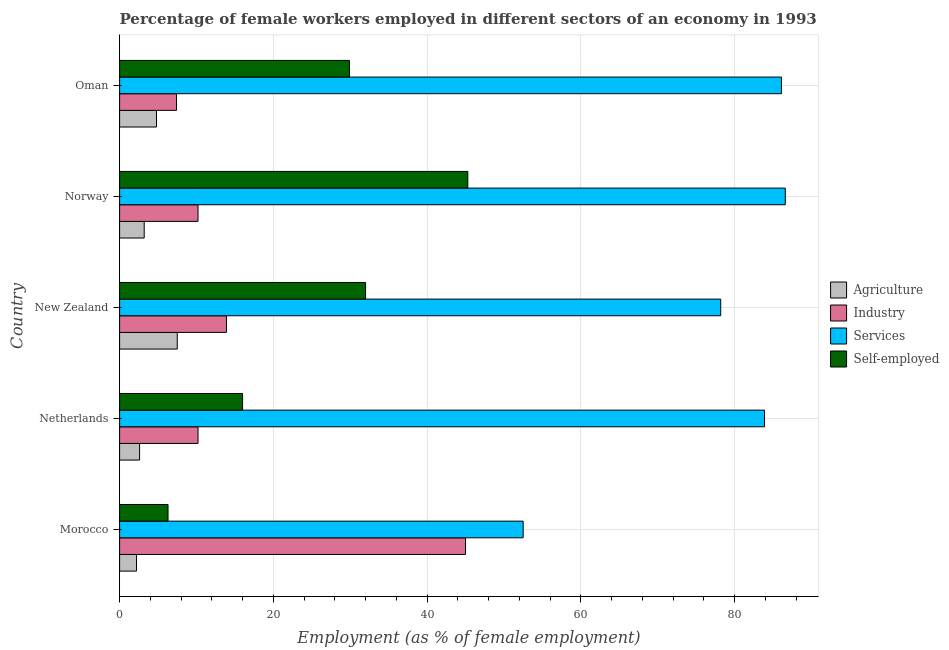Are the number of bars on each tick of the Y-axis equal?
Your answer should be very brief. Yes. What is the label of the 1st group of bars from the top?
Keep it short and to the point. Oman. What is the percentage of female workers in industry in New Zealand?
Keep it short and to the point. 13.9. Across all countries, what is the maximum percentage of self employed female workers?
Keep it short and to the point. 45.3. Across all countries, what is the minimum percentage of self employed female workers?
Provide a short and direct response. 6.3. In which country was the percentage of female workers in agriculture maximum?
Your response must be concise. New Zealand. In which country was the percentage of female workers in agriculture minimum?
Your answer should be compact. Morocco. What is the total percentage of female workers in agriculture in the graph?
Keep it short and to the point. 20.3. What is the difference between the percentage of female workers in agriculture in Norway and the percentage of female workers in industry in Morocco?
Offer a terse response. -41.8. What is the average percentage of female workers in agriculture per country?
Provide a succinct answer. 4.06. What is the difference between the percentage of female workers in agriculture and percentage of female workers in industry in Morocco?
Your response must be concise. -42.8. In how many countries, is the percentage of self employed female workers greater than 32 %?
Your answer should be very brief. 1. What is the ratio of the percentage of self employed female workers in Morocco to that in Norway?
Ensure brevity in your answer.  0.14. Is the difference between the percentage of self employed female workers in Morocco and New Zealand greater than the difference between the percentage of female workers in services in Morocco and New Zealand?
Offer a terse response. No. What is the difference between the highest and the second highest percentage of self employed female workers?
Your answer should be compact. 13.3. What is the difference between the highest and the lowest percentage of female workers in industry?
Give a very brief answer. 37.6. In how many countries, is the percentage of female workers in industry greater than the average percentage of female workers in industry taken over all countries?
Keep it short and to the point. 1. What does the 2nd bar from the top in Morocco represents?
Provide a short and direct response. Services. What does the 4th bar from the bottom in Oman represents?
Give a very brief answer. Self-employed. Is it the case that in every country, the sum of the percentage of female workers in agriculture and percentage of female workers in industry is greater than the percentage of female workers in services?
Provide a succinct answer. No. How many bars are there?
Make the answer very short. 20. How many countries are there in the graph?
Your response must be concise. 5. Does the graph contain any zero values?
Ensure brevity in your answer.  No. Where does the legend appear in the graph?
Your answer should be very brief. Center right. How many legend labels are there?
Your answer should be compact. 4. What is the title of the graph?
Your answer should be very brief. Percentage of female workers employed in different sectors of an economy in 1993. What is the label or title of the X-axis?
Make the answer very short. Employment (as % of female employment). What is the Employment (as % of female employment) of Agriculture in Morocco?
Provide a short and direct response. 2.2. What is the Employment (as % of female employment) of Services in Morocco?
Keep it short and to the point. 52.5. What is the Employment (as % of female employment) of Self-employed in Morocco?
Your answer should be very brief. 6.3. What is the Employment (as % of female employment) in Agriculture in Netherlands?
Your answer should be compact. 2.6. What is the Employment (as % of female employment) in Industry in Netherlands?
Offer a very short reply. 10.2. What is the Employment (as % of female employment) in Services in Netherlands?
Your answer should be compact. 83.9. What is the Employment (as % of female employment) of Self-employed in Netherlands?
Your answer should be very brief. 16. What is the Employment (as % of female employment) in Agriculture in New Zealand?
Give a very brief answer. 7.5. What is the Employment (as % of female employment) in Industry in New Zealand?
Give a very brief answer. 13.9. What is the Employment (as % of female employment) in Services in New Zealand?
Offer a very short reply. 78.2. What is the Employment (as % of female employment) in Self-employed in New Zealand?
Provide a succinct answer. 32. What is the Employment (as % of female employment) in Agriculture in Norway?
Your answer should be very brief. 3.2. What is the Employment (as % of female employment) of Industry in Norway?
Ensure brevity in your answer.  10.2. What is the Employment (as % of female employment) of Services in Norway?
Give a very brief answer. 86.6. What is the Employment (as % of female employment) of Self-employed in Norway?
Offer a terse response. 45.3. What is the Employment (as % of female employment) in Agriculture in Oman?
Offer a terse response. 4.8. What is the Employment (as % of female employment) of Industry in Oman?
Provide a short and direct response. 7.4. What is the Employment (as % of female employment) of Services in Oman?
Provide a short and direct response. 86.1. What is the Employment (as % of female employment) of Self-employed in Oman?
Make the answer very short. 29.9. Across all countries, what is the maximum Employment (as % of female employment) in Services?
Your response must be concise. 86.6. Across all countries, what is the maximum Employment (as % of female employment) in Self-employed?
Give a very brief answer. 45.3. Across all countries, what is the minimum Employment (as % of female employment) in Agriculture?
Give a very brief answer. 2.2. Across all countries, what is the minimum Employment (as % of female employment) of Industry?
Make the answer very short. 7.4. Across all countries, what is the minimum Employment (as % of female employment) of Services?
Keep it short and to the point. 52.5. Across all countries, what is the minimum Employment (as % of female employment) of Self-employed?
Give a very brief answer. 6.3. What is the total Employment (as % of female employment) of Agriculture in the graph?
Your response must be concise. 20.3. What is the total Employment (as % of female employment) in Industry in the graph?
Keep it short and to the point. 86.7. What is the total Employment (as % of female employment) of Services in the graph?
Give a very brief answer. 387.3. What is the total Employment (as % of female employment) of Self-employed in the graph?
Keep it short and to the point. 129.5. What is the difference between the Employment (as % of female employment) of Agriculture in Morocco and that in Netherlands?
Your answer should be very brief. -0.4. What is the difference between the Employment (as % of female employment) of Industry in Morocco and that in Netherlands?
Make the answer very short. 34.8. What is the difference between the Employment (as % of female employment) in Services in Morocco and that in Netherlands?
Make the answer very short. -31.4. What is the difference between the Employment (as % of female employment) in Industry in Morocco and that in New Zealand?
Your answer should be very brief. 31.1. What is the difference between the Employment (as % of female employment) of Services in Morocco and that in New Zealand?
Offer a terse response. -25.7. What is the difference between the Employment (as % of female employment) of Self-employed in Morocco and that in New Zealand?
Offer a very short reply. -25.7. What is the difference between the Employment (as % of female employment) in Industry in Morocco and that in Norway?
Provide a succinct answer. 34.8. What is the difference between the Employment (as % of female employment) in Services in Morocco and that in Norway?
Offer a terse response. -34.1. What is the difference between the Employment (as % of female employment) of Self-employed in Morocco and that in Norway?
Give a very brief answer. -39. What is the difference between the Employment (as % of female employment) of Agriculture in Morocco and that in Oman?
Ensure brevity in your answer.  -2.6. What is the difference between the Employment (as % of female employment) in Industry in Morocco and that in Oman?
Offer a terse response. 37.6. What is the difference between the Employment (as % of female employment) in Services in Morocco and that in Oman?
Offer a terse response. -33.6. What is the difference between the Employment (as % of female employment) of Self-employed in Morocco and that in Oman?
Offer a very short reply. -23.6. What is the difference between the Employment (as % of female employment) in Self-employed in Netherlands and that in New Zealand?
Your response must be concise. -16. What is the difference between the Employment (as % of female employment) of Industry in Netherlands and that in Norway?
Offer a very short reply. 0. What is the difference between the Employment (as % of female employment) in Services in Netherlands and that in Norway?
Make the answer very short. -2.7. What is the difference between the Employment (as % of female employment) in Self-employed in Netherlands and that in Norway?
Keep it short and to the point. -29.3. What is the difference between the Employment (as % of female employment) of Agriculture in Netherlands and that in Oman?
Ensure brevity in your answer.  -2.2. What is the difference between the Employment (as % of female employment) in Services in New Zealand and that in Norway?
Provide a succinct answer. -8.4. What is the difference between the Employment (as % of female employment) in Industry in New Zealand and that in Oman?
Offer a terse response. 6.5. What is the difference between the Employment (as % of female employment) of Agriculture in Morocco and the Employment (as % of female employment) of Services in Netherlands?
Keep it short and to the point. -81.7. What is the difference between the Employment (as % of female employment) of Agriculture in Morocco and the Employment (as % of female employment) of Self-employed in Netherlands?
Offer a very short reply. -13.8. What is the difference between the Employment (as % of female employment) in Industry in Morocco and the Employment (as % of female employment) in Services in Netherlands?
Keep it short and to the point. -38.9. What is the difference between the Employment (as % of female employment) of Industry in Morocco and the Employment (as % of female employment) of Self-employed in Netherlands?
Make the answer very short. 29. What is the difference between the Employment (as % of female employment) in Services in Morocco and the Employment (as % of female employment) in Self-employed in Netherlands?
Provide a succinct answer. 36.5. What is the difference between the Employment (as % of female employment) of Agriculture in Morocco and the Employment (as % of female employment) of Industry in New Zealand?
Your answer should be very brief. -11.7. What is the difference between the Employment (as % of female employment) of Agriculture in Morocco and the Employment (as % of female employment) of Services in New Zealand?
Offer a very short reply. -76. What is the difference between the Employment (as % of female employment) of Agriculture in Morocco and the Employment (as % of female employment) of Self-employed in New Zealand?
Your answer should be very brief. -29.8. What is the difference between the Employment (as % of female employment) in Industry in Morocco and the Employment (as % of female employment) in Services in New Zealand?
Offer a terse response. -33.2. What is the difference between the Employment (as % of female employment) in Services in Morocco and the Employment (as % of female employment) in Self-employed in New Zealand?
Offer a terse response. 20.5. What is the difference between the Employment (as % of female employment) of Agriculture in Morocco and the Employment (as % of female employment) of Services in Norway?
Offer a very short reply. -84.4. What is the difference between the Employment (as % of female employment) in Agriculture in Morocco and the Employment (as % of female employment) in Self-employed in Norway?
Keep it short and to the point. -43.1. What is the difference between the Employment (as % of female employment) in Industry in Morocco and the Employment (as % of female employment) in Services in Norway?
Your answer should be compact. -41.6. What is the difference between the Employment (as % of female employment) of Services in Morocco and the Employment (as % of female employment) of Self-employed in Norway?
Your response must be concise. 7.2. What is the difference between the Employment (as % of female employment) of Agriculture in Morocco and the Employment (as % of female employment) of Industry in Oman?
Provide a succinct answer. -5.2. What is the difference between the Employment (as % of female employment) of Agriculture in Morocco and the Employment (as % of female employment) of Services in Oman?
Offer a very short reply. -83.9. What is the difference between the Employment (as % of female employment) of Agriculture in Morocco and the Employment (as % of female employment) of Self-employed in Oman?
Make the answer very short. -27.7. What is the difference between the Employment (as % of female employment) of Industry in Morocco and the Employment (as % of female employment) of Services in Oman?
Your response must be concise. -41.1. What is the difference between the Employment (as % of female employment) in Industry in Morocco and the Employment (as % of female employment) in Self-employed in Oman?
Your response must be concise. 15.1. What is the difference between the Employment (as % of female employment) of Services in Morocco and the Employment (as % of female employment) of Self-employed in Oman?
Your response must be concise. 22.6. What is the difference between the Employment (as % of female employment) of Agriculture in Netherlands and the Employment (as % of female employment) of Industry in New Zealand?
Give a very brief answer. -11.3. What is the difference between the Employment (as % of female employment) in Agriculture in Netherlands and the Employment (as % of female employment) in Services in New Zealand?
Make the answer very short. -75.6. What is the difference between the Employment (as % of female employment) of Agriculture in Netherlands and the Employment (as % of female employment) of Self-employed in New Zealand?
Your answer should be very brief. -29.4. What is the difference between the Employment (as % of female employment) of Industry in Netherlands and the Employment (as % of female employment) of Services in New Zealand?
Offer a very short reply. -68. What is the difference between the Employment (as % of female employment) in Industry in Netherlands and the Employment (as % of female employment) in Self-employed in New Zealand?
Provide a short and direct response. -21.8. What is the difference between the Employment (as % of female employment) in Services in Netherlands and the Employment (as % of female employment) in Self-employed in New Zealand?
Give a very brief answer. 51.9. What is the difference between the Employment (as % of female employment) of Agriculture in Netherlands and the Employment (as % of female employment) of Industry in Norway?
Offer a very short reply. -7.6. What is the difference between the Employment (as % of female employment) in Agriculture in Netherlands and the Employment (as % of female employment) in Services in Norway?
Offer a very short reply. -84. What is the difference between the Employment (as % of female employment) of Agriculture in Netherlands and the Employment (as % of female employment) of Self-employed in Norway?
Your response must be concise. -42.7. What is the difference between the Employment (as % of female employment) in Industry in Netherlands and the Employment (as % of female employment) in Services in Norway?
Give a very brief answer. -76.4. What is the difference between the Employment (as % of female employment) in Industry in Netherlands and the Employment (as % of female employment) in Self-employed in Norway?
Your answer should be compact. -35.1. What is the difference between the Employment (as % of female employment) of Services in Netherlands and the Employment (as % of female employment) of Self-employed in Norway?
Give a very brief answer. 38.6. What is the difference between the Employment (as % of female employment) in Agriculture in Netherlands and the Employment (as % of female employment) in Services in Oman?
Offer a terse response. -83.5. What is the difference between the Employment (as % of female employment) of Agriculture in Netherlands and the Employment (as % of female employment) of Self-employed in Oman?
Ensure brevity in your answer.  -27.3. What is the difference between the Employment (as % of female employment) in Industry in Netherlands and the Employment (as % of female employment) in Services in Oman?
Make the answer very short. -75.9. What is the difference between the Employment (as % of female employment) of Industry in Netherlands and the Employment (as % of female employment) of Self-employed in Oman?
Ensure brevity in your answer.  -19.7. What is the difference between the Employment (as % of female employment) in Agriculture in New Zealand and the Employment (as % of female employment) in Industry in Norway?
Your answer should be very brief. -2.7. What is the difference between the Employment (as % of female employment) in Agriculture in New Zealand and the Employment (as % of female employment) in Services in Norway?
Your response must be concise. -79.1. What is the difference between the Employment (as % of female employment) in Agriculture in New Zealand and the Employment (as % of female employment) in Self-employed in Norway?
Keep it short and to the point. -37.8. What is the difference between the Employment (as % of female employment) of Industry in New Zealand and the Employment (as % of female employment) of Services in Norway?
Your response must be concise. -72.7. What is the difference between the Employment (as % of female employment) of Industry in New Zealand and the Employment (as % of female employment) of Self-employed in Norway?
Your answer should be compact. -31.4. What is the difference between the Employment (as % of female employment) of Services in New Zealand and the Employment (as % of female employment) of Self-employed in Norway?
Make the answer very short. 32.9. What is the difference between the Employment (as % of female employment) of Agriculture in New Zealand and the Employment (as % of female employment) of Services in Oman?
Offer a very short reply. -78.6. What is the difference between the Employment (as % of female employment) of Agriculture in New Zealand and the Employment (as % of female employment) of Self-employed in Oman?
Offer a very short reply. -22.4. What is the difference between the Employment (as % of female employment) of Industry in New Zealand and the Employment (as % of female employment) of Services in Oman?
Provide a short and direct response. -72.2. What is the difference between the Employment (as % of female employment) in Industry in New Zealand and the Employment (as % of female employment) in Self-employed in Oman?
Keep it short and to the point. -16. What is the difference between the Employment (as % of female employment) of Services in New Zealand and the Employment (as % of female employment) of Self-employed in Oman?
Provide a succinct answer. 48.3. What is the difference between the Employment (as % of female employment) in Agriculture in Norway and the Employment (as % of female employment) in Services in Oman?
Give a very brief answer. -82.9. What is the difference between the Employment (as % of female employment) in Agriculture in Norway and the Employment (as % of female employment) in Self-employed in Oman?
Your response must be concise. -26.7. What is the difference between the Employment (as % of female employment) of Industry in Norway and the Employment (as % of female employment) of Services in Oman?
Your answer should be compact. -75.9. What is the difference between the Employment (as % of female employment) of Industry in Norway and the Employment (as % of female employment) of Self-employed in Oman?
Your answer should be very brief. -19.7. What is the difference between the Employment (as % of female employment) of Services in Norway and the Employment (as % of female employment) of Self-employed in Oman?
Offer a very short reply. 56.7. What is the average Employment (as % of female employment) of Agriculture per country?
Ensure brevity in your answer.  4.06. What is the average Employment (as % of female employment) of Industry per country?
Make the answer very short. 17.34. What is the average Employment (as % of female employment) in Services per country?
Your answer should be compact. 77.46. What is the average Employment (as % of female employment) in Self-employed per country?
Offer a very short reply. 25.9. What is the difference between the Employment (as % of female employment) in Agriculture and Employment (as % of female employment) in Industry in Morocco?
Provide a succinct answer. -42.8. What is the difference between the Employment (as % of female employment) of Agriculture and Employment (as % of female employment) of Services in Morocco?
Keep it short and to the point. -50.3. What is the difference between the Employment (as % of female employment) in Agriculture and Employment (as % of female employment) in Self-employed in Morocco?
Ensure brevity in your answer.  -4.1. What is the difference between the Employment (as % of female employment) of Industry and Employment (as % of female employment) of Services in Morocco?
Ensure brevity in your answer.  -7.5. What is the difference between the Employment (as % of female employment) of Industry and Employment (as % of female employment) of Self-employed in Morocco?
Your answer should be compact. 38.7. What is the difference between the Employment (as % of female employment) of Services and Employment (as % of female employment) of Self-employed in Morocco?
Your response must be concise. 46.2. What is the difference between the Employment (as % of female employment) in Agriculture and Employment (as % of female employment) in Services in Netherlands?
Your answer should be compact. -81.3. What is the difference between the Employment (as % of female employment) of Industry and Employment (as % of female employment) of Services in Netherlands?
Offer a terse response. -73.7. What is the difference between the Employment (as % of female employment) of Industry and Employment (as % of female employment) of Self-employed in Netherlands?
Offer a very short reply. -5.8. What is the difference between the Employment (as % of female employment) of Services and Employment (as % of female employment) of Self-employed in Netherlands?
Offer a terse response. 67.9. What is the difference between the Employment (as % of female employment) in Agriculture and Employment (as % of female employment) in Industry in New Zealand?
Provide a succinct answer. -6.4. What is the difference between the Employment (as % of female employment) in Agriculture and Employment (as % of female employment) in Services in New Zealand?
Ensure brevity in your answer.  -70.7. What is the difference between the Employment (as % of female employment) in Agriculture and Employment (as % of female employment) in Self-employed in New Zealand?
Provide a succinct answer. -24.5. What is the difference between the Employment (as % of female employment) of Industry and Employment (as % of female employment) of Services in New Zealand?
Provide a succinct answer. -64.3. What is the difference between the Employment (as % of female employment) in Industry and Employment (as % of female employment) in Self-employed in New Zealand?
Your response must be concise. -18.1. What is the difference between the Employment (as % of female employment) of Services and Employment (as % of female employment) of Self-employed in New Zealand?
Make the answer very short. 46.2. What is the difference between the Employment (as % of female employment) of Agriculture and Employment (as % of female employment) of Industry in Norway?
Make the answer very short. -7. What is the difference between the Employment (as % of female employment) in Agriculture and Employment (as % of female employment) in Services in Norway?
Offer a very short reply. -83.4. What is the difference between the Employment (as % of female employment) of Agriculture and Employment (as % of female employment) of Self-employed in Norway?
Give a very brief answer. -42.1. What is the difference between the Employment (as % of female employment) in Industry and Employment (as % of female employment) in Services in Norway?
Ensure brevity in your answer.  -76.4. What is the difference between the Employment (as % of female employment) of Industry and Employment (as % of female employment) of Self-employed in Norway?
Ensure brevity in your answer.  -35.1. What is the difference between the Employment (as % of female employment) of Services and Employment (as % of female employment) of Self-employed in Norway?
Your answer should be compact. 41.3. What is the difference between the Employment (as % of female employment) of Agriculture and Employment (as % of female employment) of Services in Oman?
Provide a short and direct response. -81.3. What is the difference between the Employment (as % of female employment) in Agriculture and Employment (as % of female employment) in Self-employed in Oman?
Keep it short and to the point. -25.1. What is the difference between the Employment (as % of female employment) in Industry and Employment (as % of female employment) in Services in Oman?
Your answer should be compact. -78.7. What is the difference between the Employment (as % of female employment) of Industry and Employment (as % of female employment) of Self-employed in Oman?
Ensure brevity in your answer.  -22.5. What is the difference between the Employment (as % of female employment) of Services and Employment (as % of female employment) of Self-employed in Oman?
Offer a very short reply. 56.2. What is the ratio of the Employment (as % of female employment) in Agriculture in Morocco to that in Netherlands?
Your response must be concise. 0.85. What is the ratio of the Employment (as % of female employment) in Industry in Morocco to that in Netherlands?
Ensure brevity in your answer.  4.41. What is the ratio of the Employment (as % of female employment) of Services in Morocco to that in Netherlands?
Make the answer very short. 0.63. What is the ratio of the Employment (as % of female employment) in Self-employed in Morocco to that in Netherlands?
Give a very brief answer. 0.39. What is the ratio of the Employment (as % of female employment) in Agriculture in Morocco to that in New Zealand?
Your answer should be compact. 0.29. What is the ratio of the Employment (as % of female employment) in Industry in Morocco to that in New Zealand?
Offer a very short reply. 3.24. What is the ratio of the Employment (as % of female employment) in Services in Morocco to that in New Zealand?
Ensure brevity in your answer.  0.67. What is the ratio of the Employment (as % of female employment) in Self-employed in Morocco to that in New Zealand?
Your answer should be compact. 0.2. What is the ratio of the Employment (as % of female employment) in Agriculture in Morocco to that in Norway?
Offer a very short reply. 0.69. What is the ratio of the Employment (as % of female employment) of Industry in Morocco to that in Norway?
Provide a short and direct response. 4.41. What is the ratio of the Employment (as % of female employment) in Services in Morocco to that in Norway?
Your answer should be very brief. 0.61. What is the ratio of the Employment (as % of female employment) in Self-employed in Morocco to that in Norway?
Make the answer very short. 0.14. What is the ratio of the Employment (as % of female employment) of Agriculture in Morocco to that in Oman?
Offer a terse response. 0.46. What is the ratio of the Employment (as % of female employment) in Industry in Morocco to that in Oman?
Give a very brief answer. 6.08. What is the ratio of the Employment (as % of female employment) of Services in Morocco to that in Oman?
Ensure brevity in your answer.  0.61. What is the ratio of the Employment (as % of female employment) in Self-employed in Morocco to that in Oman?
Your response must be concise. 0.21. What is the ratio of the Employment (as % of female employment) of Agriculture in Netherlands to that in New Zealand?
Your answer should be very brief. 0.35. What is the ratio of the Employment (as % of female employment) in Industry in Netherlands to that in New Zealand?
Provide a succinct answer. 0.73. What is the ratio of the Employment (as % of female employment) in Services in Netherlands to that in New Zealand?
Offer a terse response. 1.07. What is the ratio of the Employment (as % of female employment) in Self-employed in Netherlands to that in New Zealand?
Your response must be concise. 0.5. What is the ratio of the Employment (as % of female employment) of Agriculture in Netherlands to that in Norway?
Your response must be concise. 0.81. What is the ratio of the Employment (as % of female employment) in Services in Netherlands to that in Norway?
Your response must be concise. 0.97. What is the ratio of the Employment (as % of female employment) in Self-employed in Netherlands to that in Norway?
Your answer should be compact. 0.35. What is the ratio of the Employment (as % of female employment) of Agriculture in Netherlands to that in Oman?
Provide a succinct answer. 0.54. What is the ratio of the Employment (as % of female employment) in Industry in Netherlands to that in Oman?
Provide a short and direct response. 1.38. What is the ratio of the Employment (as % of female employment) of Services in Netherlands to that in Oman?
Offer a terse response. 0.97. What is the ratio of the Employment (as % of female employment) of Self-employed in Netherlands to that in Oman?
Give a very brief answer. 0.54. What is the ratio of the Employment (as % of female employment) in Agriculture in New Zealand to that in Norway?
Keep it short and to the point. 2.34. What is the ratio of the Employment (as % of female employment) in Industry in New Zealand to that in Norway?
Offer a very short reply. 1.36. What is the ratio of the Employment (as % of female employment) of Services in New Zealand to that in Norway?
Offer a very short reply. 0.9. What is the ratio of the Employment (as % of female employment) of Self-employed in New Zealand to that in Norway?
Offer a terse response. 0.71. What is the ratio of the Employment (as % of female employment) in Agriculture in New Zealand to that in Oman?
Your response must be concise. 1.56. What is the ratio of the Employment (as % of female employment) in Industry in New Zealand to that in Oman?
Give a very brief answer. 1.88. What is the ratio of the Employment (as % of female employment) in Services in New Zealand to that in Oman?
Keep it short and to the point. 0.91. What is the ratio of the Employment (as % of female employment) of Self-employed in New Zealand to that in Oman?
Your answer should be very brief. 1.07. What is the ratio of the Employment (as % of female employment) of Industry in Norway to that in Oman?
Your response must be concise. 1.38. What is the ratio of the Employment (as % of female employment) of Services in Norway to that in Oman?
Your answer should be compact. 1.01. What is the ratio of the Employment (as % of female employment) of Self-employed in Norway to that in Oman?
Offer a terse response. 1.52. What is the difference between the highest and the second highest Employment (as % of female employment) in Industry?
Offer a terse response. 31.1. What is the difference between the highest and the second highest Employment (as % of female employment) of Services?
Make the answer very short. 0.5. What is the difference between the highest and the lowest Employment (as % of female employment) in Agriculture?
Give a very brief answer. 5.3. What is the difference between the highest and the lowest Employment (as % of female employment) in Industry?
Keep it short and to the point. 37.6. What is the difference between the highest and the lowest Employment (as % of female employment) of Services?
Give a very brief answer. 34.1. What is the difference between the highest and the lowest Employment (as % of female employment) in Self-employed?
Provide a succinct answer. 39. 